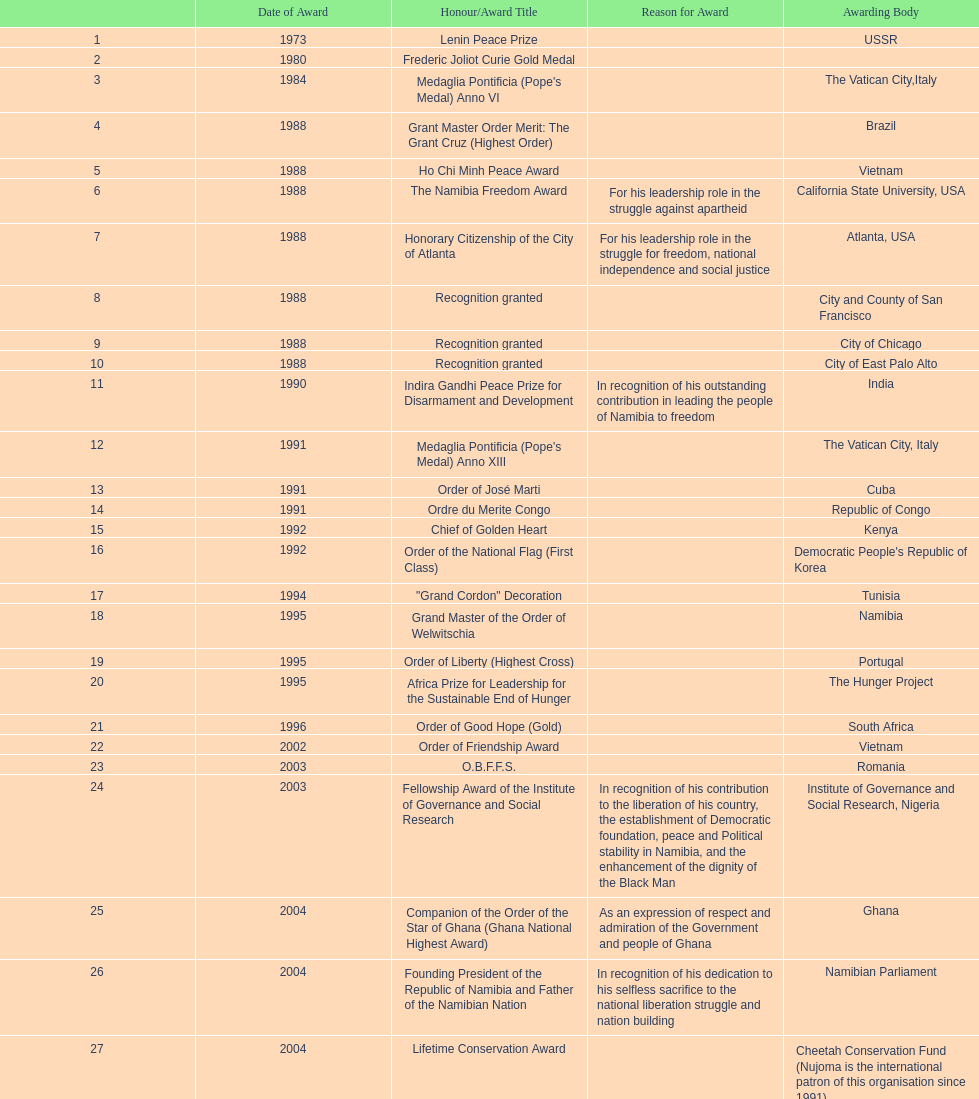In which year were the highest number of honors/award titles awarded? 1988. 